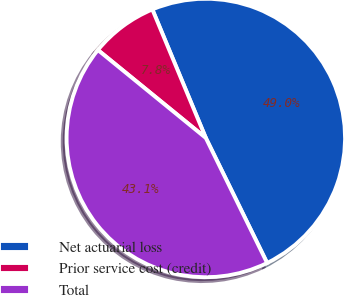Convert chart to OTSL. <chart><loc_0><loc_0><loc_500><loc_500><pie_chart><fcel>Net actuarial loss<fcel>Prior service cost (credit)<fcel>Total<nl><fcel>49.02%<fcel>7.84%<fcel>43.14%<nl></chart> 